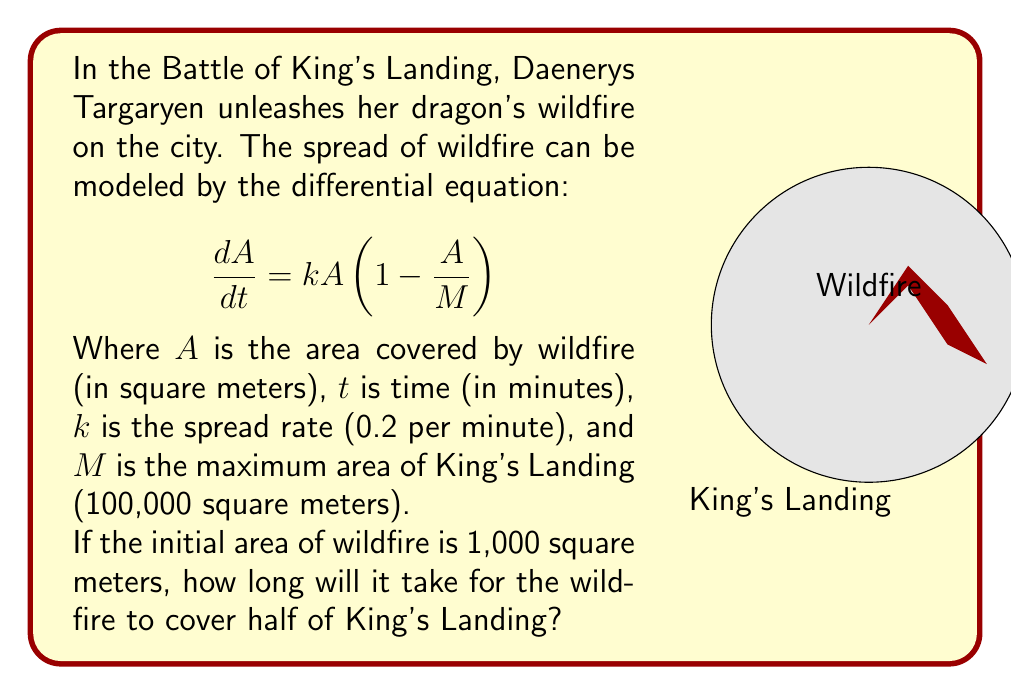Help me with this question. Let's approach this step-by-step:

1) First, we need to solve the differential equation. This is a logistic growth model, and its solution is:

   $$A(t) = \frac{MA_0e^{kt}}{M + A_0(e^{kt} - 1)}$$

   Where $A_0$ is the initial area.

2) We're given:
   $M = 100,000$ sq meters
   $k = 0.2$ per minute
   $A_0 = 1,000$ sq meters

3) We want to find $t$ when $A(t) = 50,000$ sq meters (half of King's Landing)

4) Substituting these values into our equation:

   $$50,000 = \frac{100,000 \cdot 1,000 \cdot e^{0.2t}}{100,000 + 1,000(e^{0.2t} - 1)}$$

5) Simplifying:

   $$50,000 = \frac{100,000,000 \cdot e^{0.2t}}{100,000 + 1,000e^{0.2t} - 1,000}$$

6) Multiplying both sides:

   $$5,000,000 + 50,000e^{0.2t} - 50,000 = 100,000,000 \cdot e^{0.2t}$$

7) Rearranging:

   $$99,950,000 \cdot e^{0.2t} - 50,000e^{0.2t} = 5,000,000 - 50,000$$

   $$99,900,000 \cdot e^{0.2t} = 4,950,000$$

8) Taking natural log of both sides:

   $$\ln(99,900,000) + 0.2t = \ln(4,950,000)$$

9) Solving for $t$:

   $$t = \frac{\ln(4,950,000) - \ln(99,900,000)}{0.2}$$

10) Calculating:

    $$t \approx 15.34$$ minutes
Answer: $15.34$ minutes 